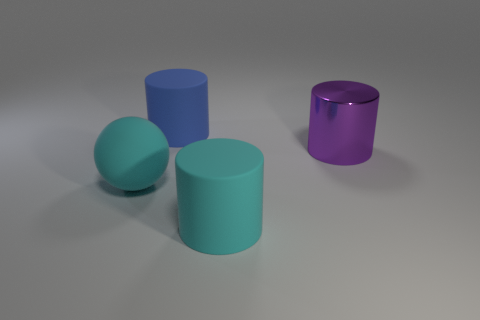Subtract all big blue cylinders. How many cylinders are left? 2 Subtract all cyan cylinders. How many cylinders are left? 2 Add 3 big purple cylinders. How many objects exist? 7 Subtract 1 cylinders. How many cylinders are left? 2 Subtract 1 blue cylinders. How many objects are left? 3 Subtract all spheres. How many objects are left? 3 Subtract all green cylinders. Subtract all cyan blocks. How many cylinders are left? 3 Subtract all tiny cyan rubber cylinders. Subtract all shiny cylinders. How many objects are left? 3 Add 4 large cylinders. How many large cylinders are left? 7 Add 4 small purple metallic cubes. How many small purple metallic cubes exist? 4 